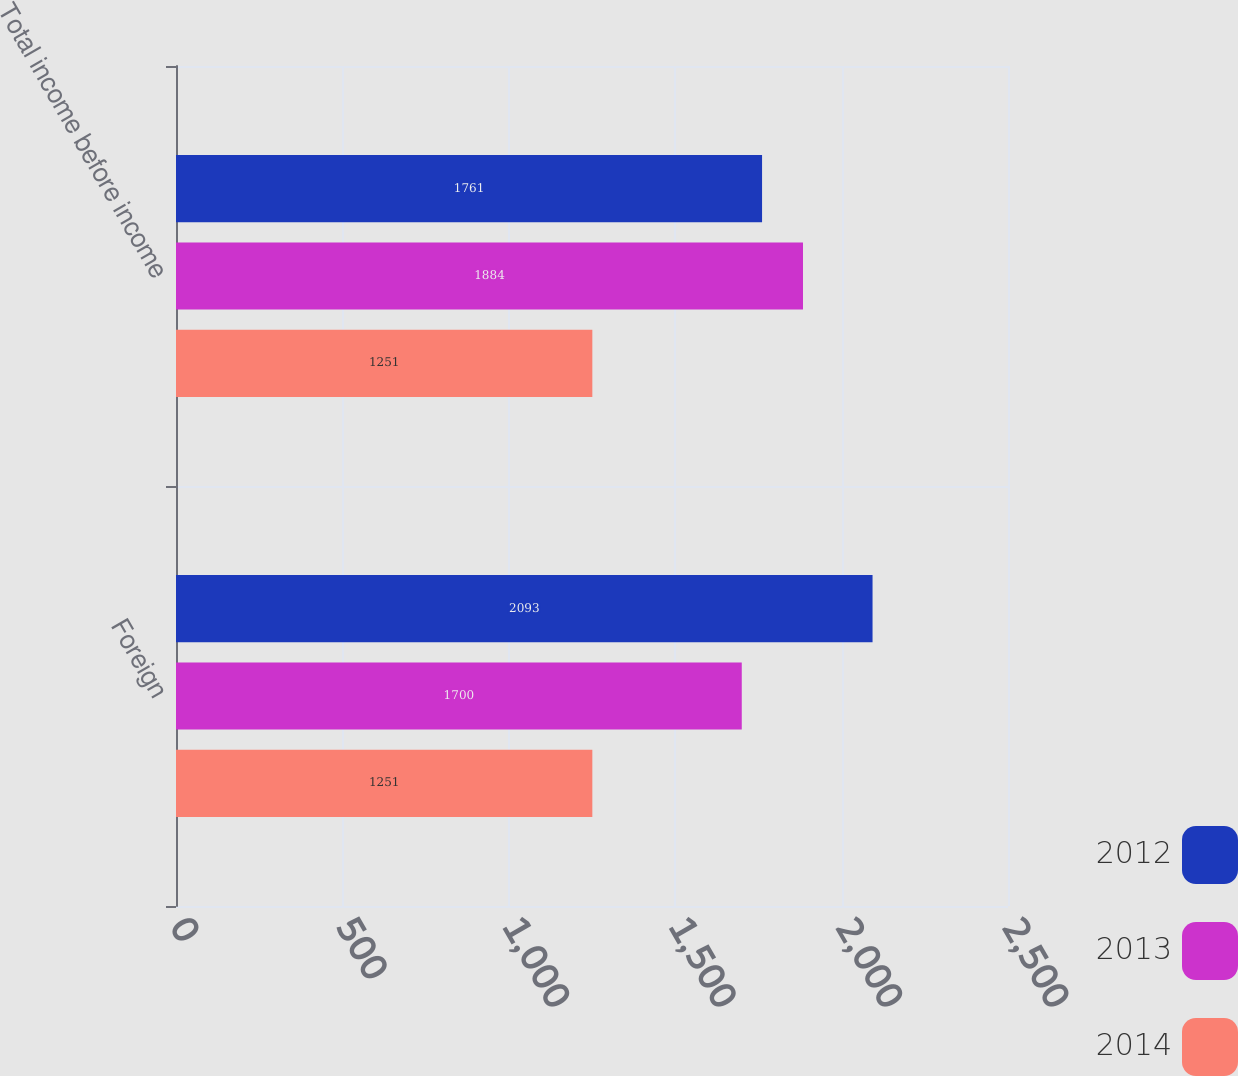Convert chart. <chart><loc_0><loc_0><loc_500><loc_500><stacked_bar_chart><ecel><fcel>Foreign<fcel>Total income before income<nl><fcel>2012<fcel>2093<fcel>1761<nl><fcel>2013<fcel>1700<fcel>1884<nl><fcel>2014<fcel>1251<fcel>1251<nl></chart> 